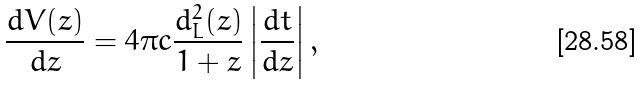Convert formula to latex. <formula><loc_0><loc_0><loc_500><loc_500>\frac { d V ( z ) } { d z } = 4 \pi c \frac { d _ { L } ^ { 2 } ( z ) } { 1 + z } \left | \frac { d t } { d z } \right | ,</formula> 